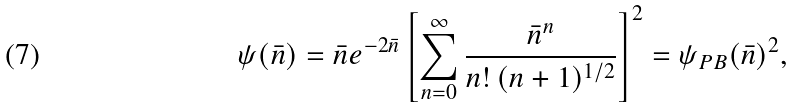Convert formula to latex. <formula><loc_0><loc_0><loc_500><loc_500>\psi ( \bar { n } ) = \bar { n } e ^ { - 2 \bar { n } } \left [ \sum _ { n = 0 } ^ { \infty } \frac { \bar { n } ^ { n } } { n ! \, ( n + 1 ) ^ { 1 / 2 } } \right ] ^ { 2 } = \psi _ { P B } ( { \bar { n } } ) ^ { 2 } ,</formula> 